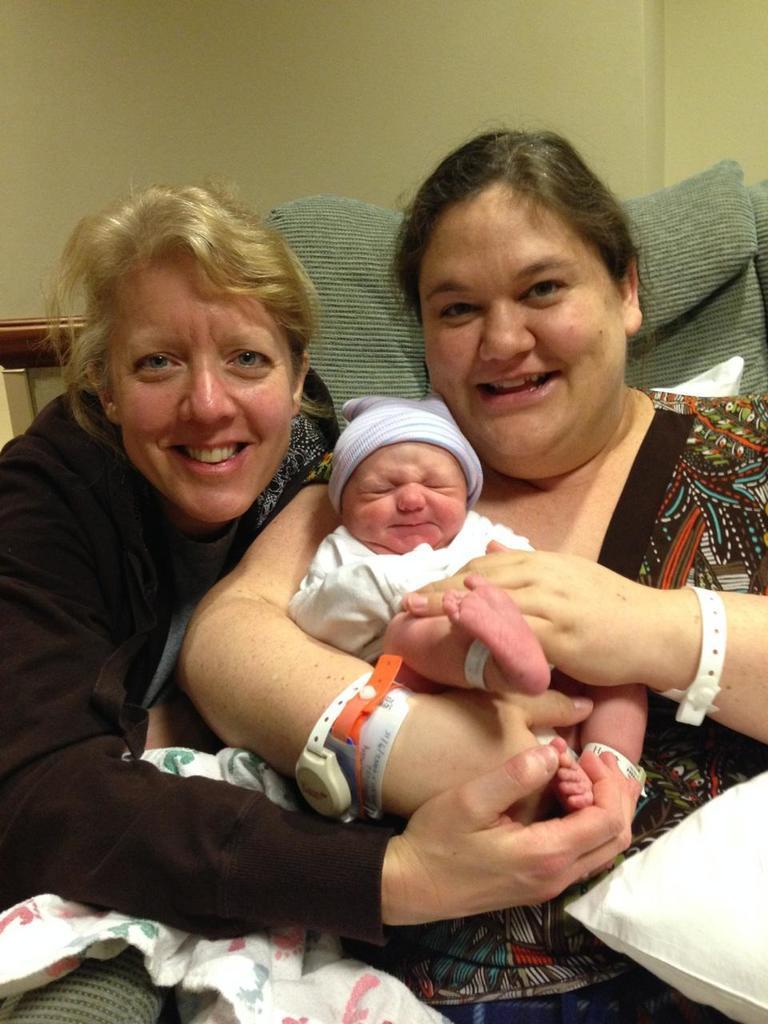How would you summarize this image in a sentence or two? There are two people smiling and holding a baby and we can see pillow. In the background we can see wall. 